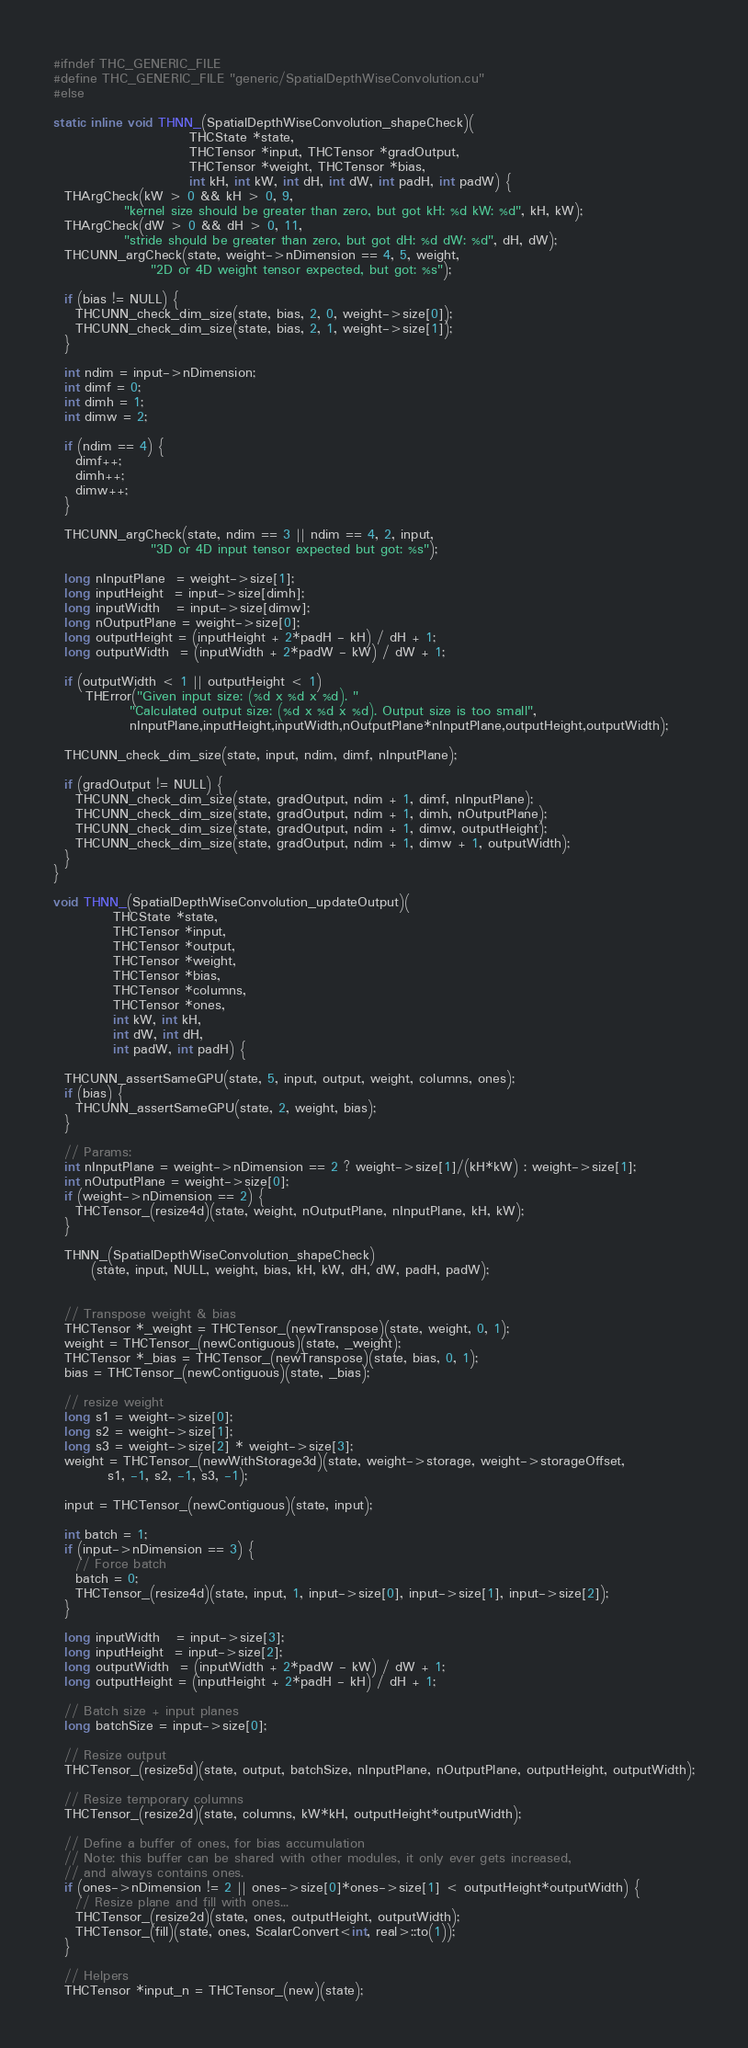<code> <loc_0><loc_0><loc_500><loc_500><_Cuda_>#ifndef THC_GENERIC_FILE
#define THC_GENERIC_FILE "generic/SpatialDepthWiseConvolution.cu"
#else

static inline void THNN_(SpatialDepthWiseConvolution_shapeCheck)(
                         THCState *state,
                         THCTensor *input, THCTensor *gradOutput,
                         THCTensor *weight, THCTensor *bias,
                         int kH, int kW, int dH, int dW, int padH, int padW) {
  THArgCheck(kW > 0 && kH > 0, 9,
             "kernel size should be greater than zero, but got kH: %d kW: %d", kH, kW);
  THArgCheck(dW > 0 && dH > 0, 11,
             "stride should be greater than zero, but got dH: %d dW: %d", dH, dW);
  THCUNN_argCheck(state, weight->nDimension == 4, 5, weight,
                  "2D or 4D weight tensor expected, but got: %s");

  if (bias != NULL) {
    THCUNN_check_dim_size(state, bias, 2, 0, weight->size[0]);
    THCUNN_check_dim_size(state, bias, 2, 1, weight->size[1]);
  }

  int ndim = input->nDimension;
  int dimf = 0;
  int dimh = 1;
  int dimw = 2;

  if (ndim == 4) {
    dimf++;
    dimh++;
    dimw++;
  }

  THCUNN_argCheck(state, ndim == 3 || ndim == 4, 2, input,
                  "3D or 4D input tensor expected but got: %s");

  long nInputPlane  = weight->size[1];
  long inputHeight  = input->size[dimh];
  long inputWidth   = input->size[dimw];
  long nOutputPlane = weight->size[0];
  long outputHeight = (inputHeight + 2*padH - kH) / dH + 1;
  long outputWidth  = (inputWidth + 2*padW - kW) / dW + 1;

  if (outputWidth < 1 || outputHeight < 1)
      THError("Given input size: (%d x %d x %d). "
              "Calculated output size: (%d x %d x %d). Output size is too small",
              nInputPlane,inputHeight,inputWidth,nOutputPlane*nInputPlane,outputHeight,outputWidth);

  THCUNN_check_dim_size(state, input, ndim, dimf, nInputPlane);

  if (gradOutput != NULL) {
    THCUNN_check_dim_size(state, gradOutput, ndim + 1, dimf, nInputPlane);
    THCUNN_check_dim_size(state, gradOutput, ndim + 1, dimh, nOutputPlane);
    THCUNN_check_dim_size(state, gradOutput, ndim + 1, dimw, outputHeight);
    THCUNN_check_dim_size(state, gradOutput, ndim + 1, dimw + 1, outputWidth);
  }
}

void THNN_(SpatialDepthWiseConvolution_updateOutput)(
           THCState *state,
           THCTensor *input,
           THCTensor *output,
           THCTensor *weight,
           THCTensor *bias,
           THCTensor *columns,
           THCTensor *ones,
           int kW, int kH,
           int dW, int dH,
           int padW, int padH) {

  THCUNN_assertSameGPU(state, 5, input, output, weight, columns, ones);
  if (bias) {
    THCUNN_assertSameGPU(state, 2, weight, bias);
  }

  // Params:
  int nInputPlane = weight->nDimension == 2 ? weight->size[1]/(kH*kW) : weight->size[1];
  int nOutputPlane = weight->size[0];
  if (weight->nDimension == 2) {
    THCTensor_(resize4d)(state, weight, nOutputPlane, nInputPlane, kH, kW);
  }

  THNN_(SpatialDepthWiseConvolution_shapeCheck)
       (state, input, NULL, weight, bias, kH, kW, dH, dW, padH, padW);


  // Transpose weight & bias
  THCTensor *_weight = THCTensor_(newTranspose)(state, weight, 0, 1);
  weight = THCTensor_(newContiguous)(state, _weight);
  THCTensor *_bias = THCTensor_(newTranspose)(state, bias, 0, 1);
  bias = THCTensor_(newContiguous)(state, _bias);

  // resize weight
  long s1 = weight->size[0];
  long s2 = weight->size[1];
  long s3 = weight->size[2] * weight->size[3];
  weight = THCTensor_(newWithStorage3d)(state, weight->storage, weight->storageOffset,
          s1, -1, s2, -1, s3, -1);

  input = THCTensor_(newContiguous)(state, input);

  int batch = 1;
  if (input->nDimension == 3) {
    // Force batch
    batch = 0;
    THCTensor_(resize4d)(state, input, 1, input->size[0], input->size[1], input->size[2]);
  }

  long inputWidth   = input->size[3];
  long inputHeight  = input->size[2];
  long outputWidth  = (inputWidth + 2*padW - kW) / dW + 1;
  long outputHeight = (inputHeight + 2*padH - kH) / dH + 1;

  // Batch size + input planes
  long batchSize = input->size[0];

  // Resize output
  THCTensor_(resize5d)(state, output, batchSize, nInputPlane, nOutputPlane, outputHeight, outputWidth);

  // Resize temporary columns
  THCTensor_(resize2d)(state, columns, kW*kH, outputHeight*outputWidth);

  // Define a buffer of ones, for bias accumulation
  // Note: this buffer can be shared with other modules, it only ever gets increased,
  // and always contains ones.
  if (ones->nDimension != 2 || ones->size[0]*ones->size[1] < outputHeight*outputWidth) {
    // Resize plane and fill with ones...
    THCTensor_(resize2d)(state, ones, outputHeight, outputWidth);
    THCTensor_(fill)(state, ones, ScalarConvert<int, real>::to(1));
  }

  // Helpers
  THCTensor *input_n = THCTensor_(new)(state);</code> 